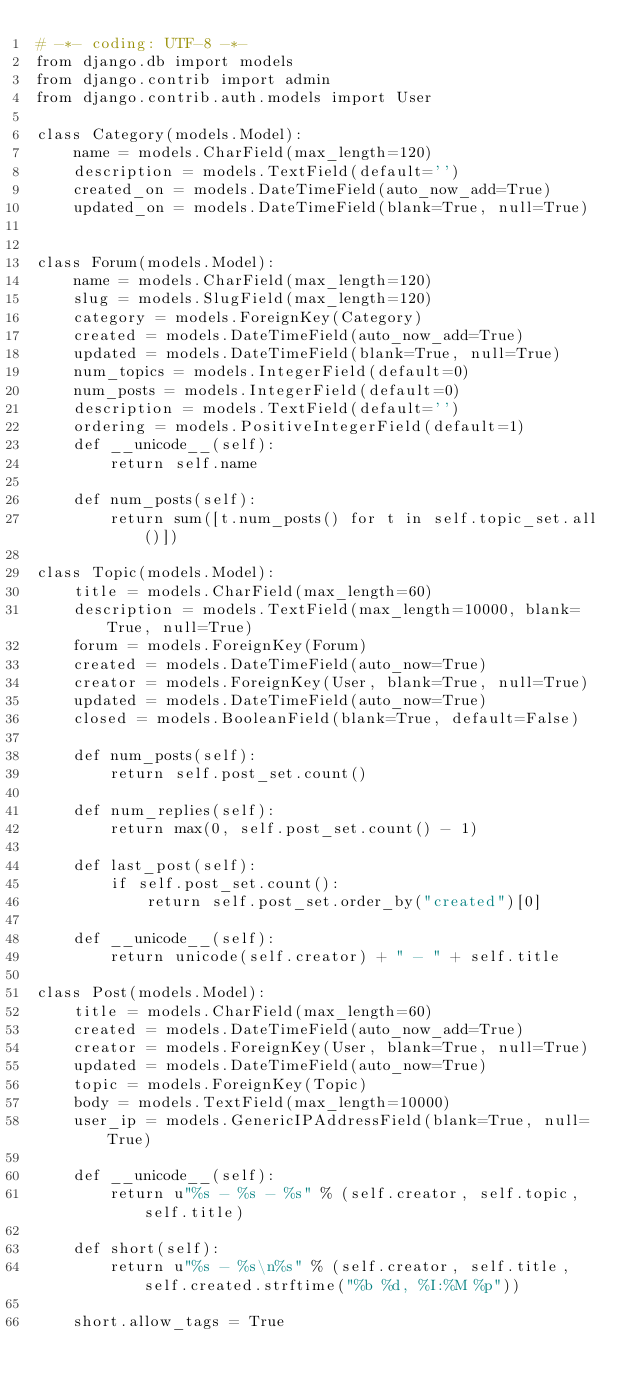Convert code to text. <code><loc_0><loc_0><loc_500><loc_500><_Python_># -*- coding: UTF-8 -*-
from django.db import models
from django.contrib import admin
from django.contrib.auth.models import User

class Category(models.Model):
    name = models.CharField(max_length=120)
    description = models.TextField(default='')
    created_on = models.DateTimeField(auto_now_add=True)
    updated_on = models.DateTimeField(blank=True, null=True)


class Forum(models.Model):
    name = models.CharField(max_length=120)
    slug = models.SlugField(max_length=120)
    category = models.ForeignKey(Category)
    created = models.DateTimeField(auto_now_add=True)
    updated = models.DateTimeField(blank=True, null=True)
    num_topics = models.IntegerField(default=0)
    num_posts = models.IntegerField(default=0)
    description = models.TextField(default='')
    ordering = models.PositiveIntegerField(default=1)
    def __unicode__(self):
        return self.name

    def num_posts(self):
        return sum([t.num_posts() for t in self.topic_set.all()])
		
class Topic(models.Model):
    title = models.CharField(max_length=60)
    description = models.TextField(max_length=10000, blank=True, null=True)
    forum = models.ForeignKey(Forum)
    created = models.DateTimeField(auto_now=True)
    creator = models.ForeignKey(User, blank=True, null=True)
    updated = models.DateTimeField(auto_now=True)
    closed = models.BooleanField(blank=True, default=False)

    def num_posts(self):
        return self.post_set.count()

    def num_replies(self):
        return max(0, self.post_set.count() - 1)

    def last_post(self):
        if self.post_set.count():
            return self.post_set.order_by("created")[0]

    def __unicode__(self):
        return unicode(self.creator) + " - " + self.title

class Post(models.Model):
    title = models.CharField(max_length=60)
    created = models.DateTimeField(auto_now_add=True)
    creator = models.ForeignKey(User, blank=True, null=True)
    updated = models.DateTimeField(auto_now=True)
    topic = models.ForeignKey(Topic)
    body = models.TextField(max_length=10000)
    user_ip = models.GenericIPAddressField(blank=True, null=True)

    def __unicode__(self):
        return u"%s - %s - %s" % (self.creator, self.topic, self.title)

    def short(self):
        return u"%s - %s\n%s" % (self.creator, self.title, self.created.strftime("%b %d, %I:%M %p"))

    short.allow_tags = True</code> 